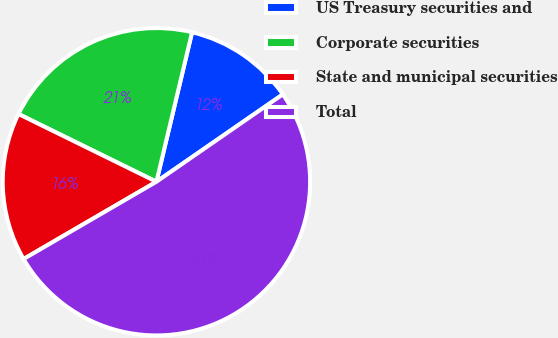Convert chart. <chart><loc_0><loc_0><loc_500><loc_500><pie_chart><fcel>US Treasury securities and<fcel>Corporate securities<fcel>State and municipal securities<fcel>Total<nl><fcel>11.65%<fcel>21.46%<fcel>15.65%<fcel>51.24%<nl></chart> 